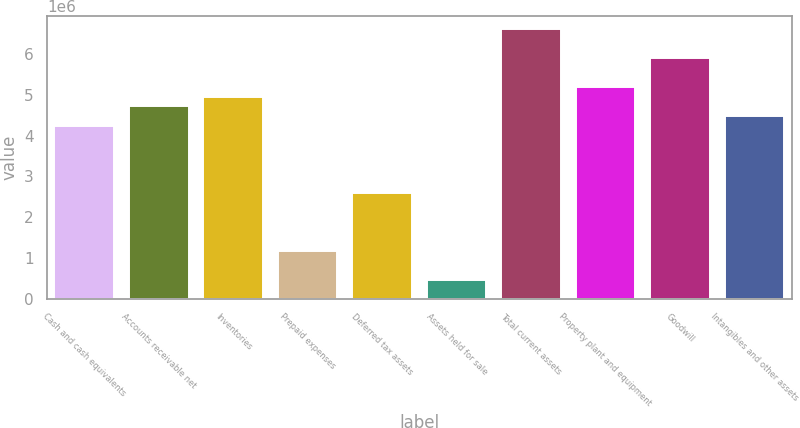Convert chart to OTSL. <chart><loc_0><loc_0><loc_500><loc_500><bar_chart><fcel>Cash and cash equivalents<fcel>Accounts receivable net<fcel>Inventories<fcel>Prepaid expenses<fcel>Deferred tax assets<fcel>Assets held for sale<fcel>Total current assets<fcel>Property plant and equipment<fcel>Goodwill<fcel>Intangibles and other assets<nl><fcel>4.24616e+06<fcel>4.71794e+06<fcel>4.95383e+06<fcel>1.17961e+06<fcel>2.59494e+06<fcel>471942<fcel>6.60505e+06<fcel>5.18972e+06<fcel>5.89738e+06<fcel>4.48205e+06<nl></chart> 